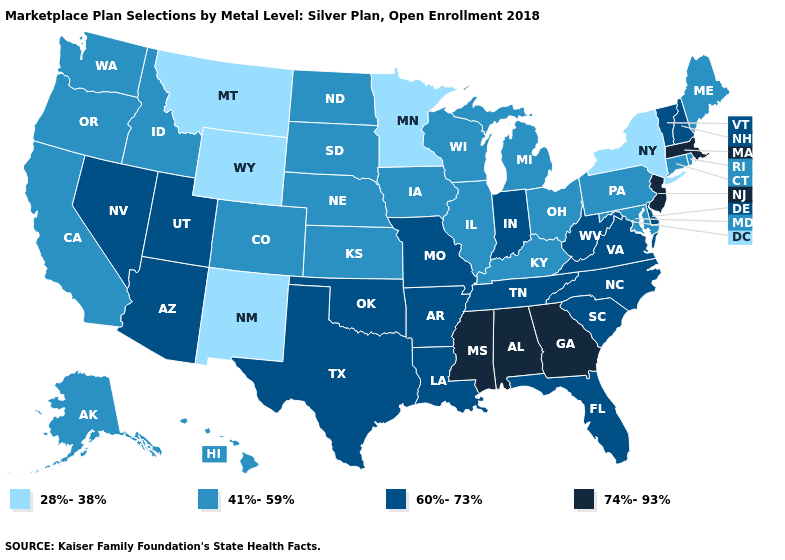Does Massachusetts have the highest value in the USA?
Write a very short answer. Yes. Does Pennsylvania have the same value as North Dakota?
Quick response, please. Yes. Name the states that have a value in the range 41%-59%?
Keep it brief. Alaska, California, Colorado, Connecticut, Hawaii, Idaho, Illinois, Iowa, Kansas, Kentucky, Maine, Maryland, Michigan, Nebraska, North Dakota, Ohio, Oregon, Pennsylvania, Rhode Island, South Dakota, Washington, Wisconsin. Which states have the lowest value in the USA?
Give a very brief answer. Minnesota, Montana, New Mexico, New York, Wyoming. What is the value of Minnesota?
Keep it brief. 28%-38%. What is the highest value in the Northeast ?
Give a very brief answer. 74%-93%. Does Alabama have the highest value in the USA?
Answer briefly. Yes. What is the highest value in states that border Mississippi?
Give a very brief answer. 74%-93%. What is the lowest value in states that border Washington?
Answer briefly. 41%-59%. Does Maryland have the lowest value in the South?
Answer briefly. Yes. Name the states that have a value in the range 41%-59%?
Answer briefly. Alaska, California, Colorado, Connecticut, Hawaii, Idaho, Illinois, Iowa, Kansas, Kentucky, Maine, Maryland, Michigan, Nebraska, North Dakota, Ohio, Oregon, Pennsylvania, Rhode Island, South Dakota, Washington, Wisconsin. What is the lowest value in the South?
Quick response, please. 41%-59%. Does New Jersey have the highest value in the USA?
Short answer required. Yes. What is the value of Ohio?
Be succinct. 41%-59%. Does Arizona have the same value as Alabama?
Keep it brief. No. 